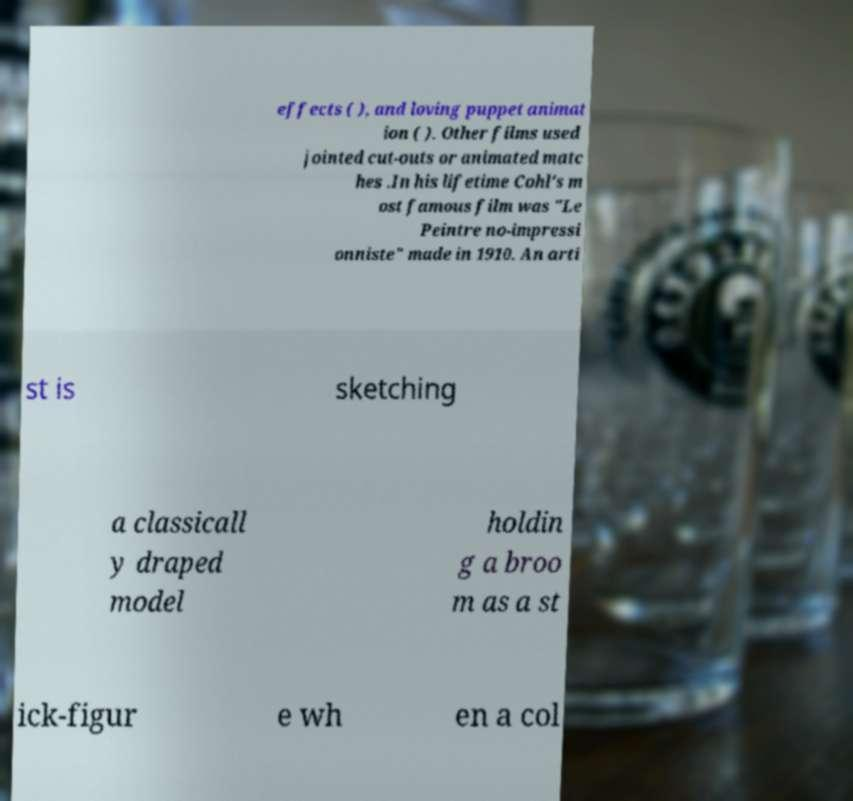For documentation purposes, I need the text within this image transcribed. Could you provide that? effects ( ), and loving puppet animat ion ( ). Other films used jointed cut-outs or animated matc hes .In his lifetime Cohl's m ost famous film was "Le Peintre no-impressi onniste" made in 1910. An arti st is sketching a classicall y draped model holdin g a broo m as a st ick-figur e wh en a col 